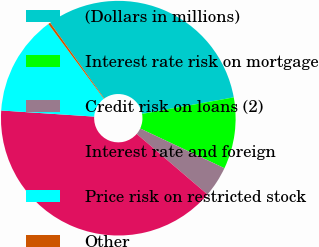<chart> <loc_0><loc_0><loc_500><loc_500><pie_chart><fcel>(Dollars in millions)<fcel>Interest rate risk on mortgage<fcel>Credit risk on loans (2)<fcel>Interest rate and foreign<fcel>Price risk on restricted stock<fcel>Other<nl><fcel>32.02%<fcel>9.85%<fcel>4.25%<fcel>39.78%<fcel>13.79%<fcel>0.3%<nl></chart> 